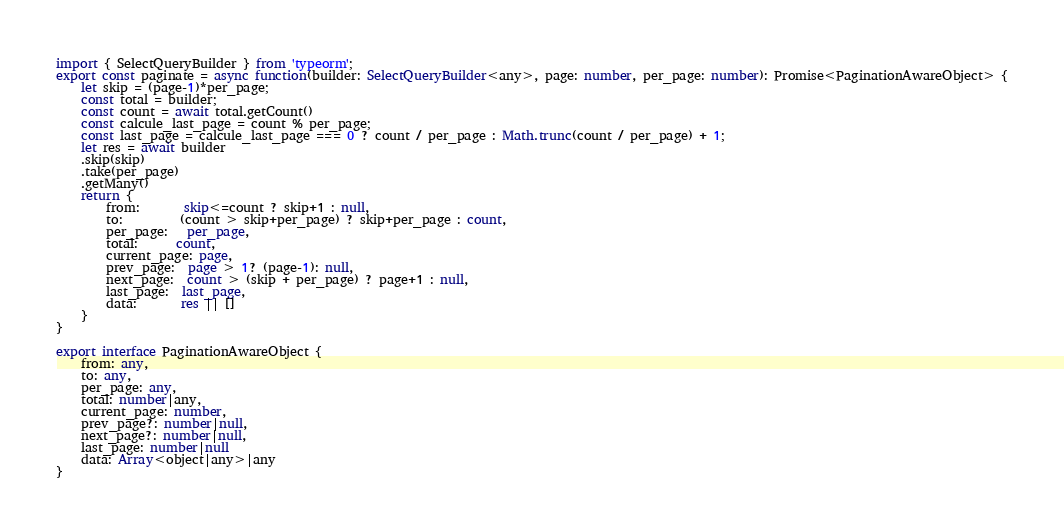<code> <loc_0><loc_0><loc_500><loc_500><_TypeScript_>import { SelectQueryBuilder } from 'typeorm';
export const paginate = async function(builder: SelectQueryBuilder<any>, page: number, per_page: number): Promise<PaginationAwareObject> {
    let skip = (page-1)*per_page;
    const total = builder;
    const count = await total.getCount()
    const calcule_last_page = count % per_page;
    const last_page = calcule_last_page === 0 ? count / per_page : Math.trunc(count / per_page) + 1;
    let res = await builder
    .skip(skip)
    .take(per_page)
    .getMany()
    return {
        from:       skip<=count ? skip+1 : null,
        to:         (count > skip+per_page) ? skip+per_page : count,
        per_page:   per_page,
        total:      count,
        current_page: page,
        prev_page:  page > 1? (page-1): null,
        next_page:  count > (skip + per_page) ? page+1 : null,
        last_page:  last_page,
        data:       res || []
    }
}

export interface PaginationAwareObject {
    from: any,
    to: any,
    per_page: any,
    total: number|any,
    current_page: number,
    prev_page?: number|null,
    next_page?: number|null,
    last_page: number|null
    data: Array<object|any>|any
}</code> 